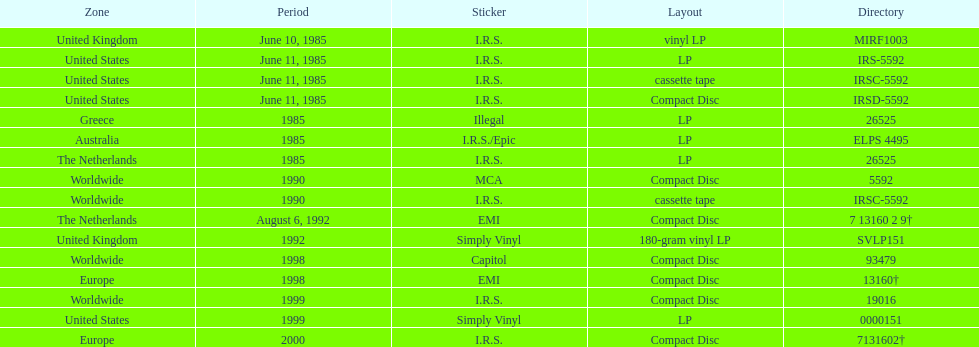Name at least two labels that released the group's albums. I.R.S., Illegal. 